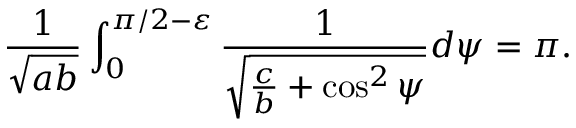<formula> <loc_0><loc_0><loc_500><loc_500>\frac { 1 } { \sqrt { a b } } \int _ { 0 } ^ { \pi / 2 - \varepsilon } \frac { 1 } { \sqrt { \frac { c } { b } + \cos ^ { 2 } \psi } } d \psi = \pi .</formula> 